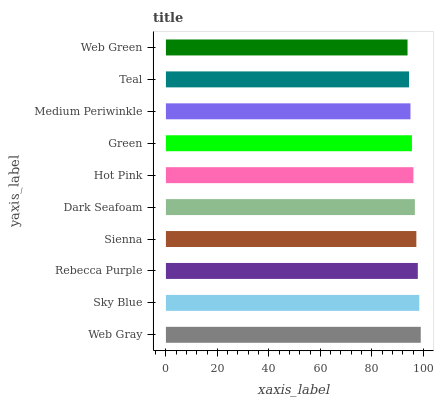Is Web Green the minimum?
Answer yes or no. Yes. Is Web Gray the maximum?
Answer yes or no. Yes. Is Sky Blue the minimum?
Answer yes or no. No. Is Sky Blue the maximum?
Answer yes or no. No. Is Web Gray greater than Sky Blue?
Answer yes or no. Yes. Is Sky Blue less than Web Gray?
Answer yes or no. Yes. Is Sky Blue greater than Web Gray?
Answer yes or no. No. Is Web Gray less than Sky Blue?
Answer yes or no. No. Is Dark Seafoam the high median?
Answer yes or no. Yes. Is Hot Pink the low median?
Answer yes or no. Yes. Is Green the high median?
Answer yes or no. No. Is Sky Blue the low median?
Answer yes or no. No. 